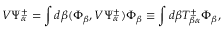<formula> <loc_0><loc_0><loc_500><loc_500>V \Psi _ { \alpha } ^ { \pm } = \int d \beta ( \Phi _ { \beta } , V \Psi _ { \alpha } ^ { \pm } ) \Phi _ { \beta } \equiv \int d \beta T _ { \beta \alpha } ^ { \pm } \Phi _ { \beta } ,</formula> 